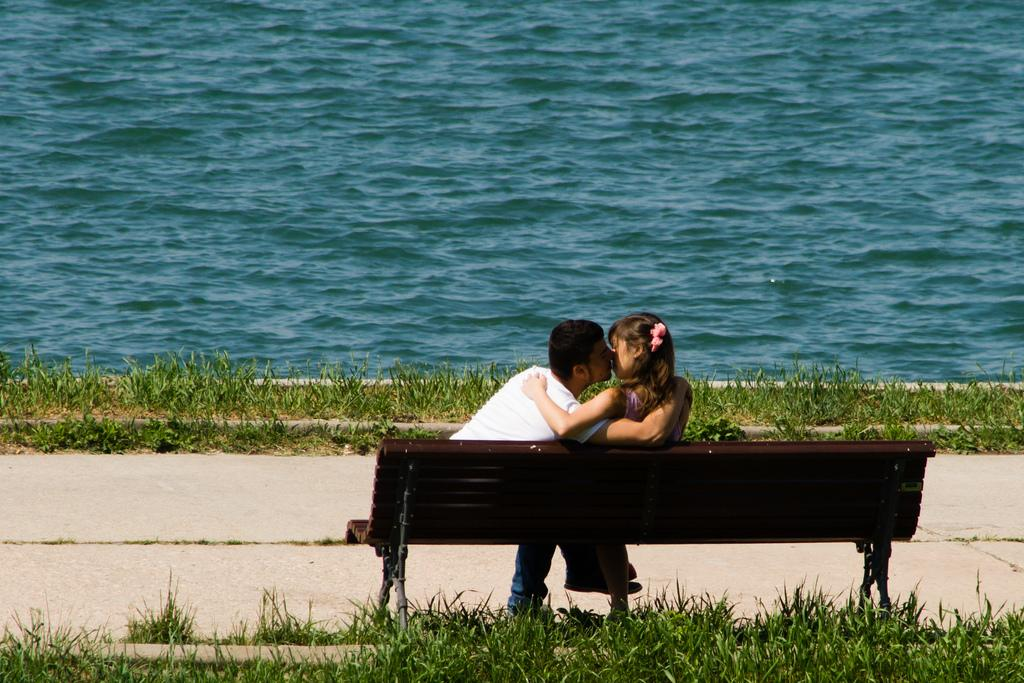Who is present in the image? There is a man and a woman in the image. What are the man and woman doing in the image? Both the man and woman are sitting on a bench. What can be seen at the top of the image? Water is visible at the top of the image. What type of vegetation is present at the bottom of the image? Grass is present at the bottom of the image. What type of plants are the cattle grazing on in the image? There are no plants or cattle present in the image. 